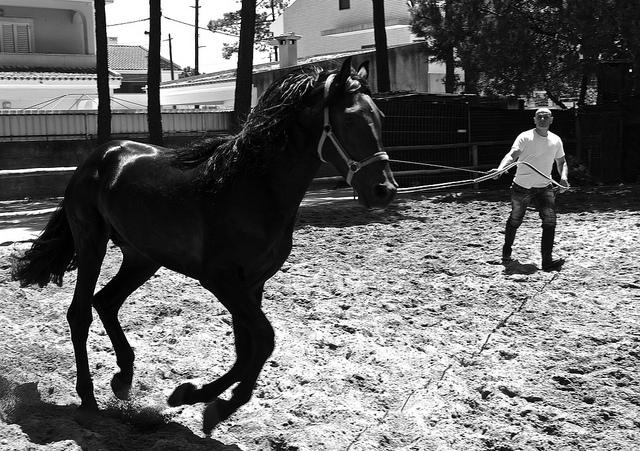Is the picture black and white?
Concise answer only. Yes. What kind of animal is in this picture?
Answer briefly. Horse. What is the man trying to do?
Concise answer only. Train horse. 